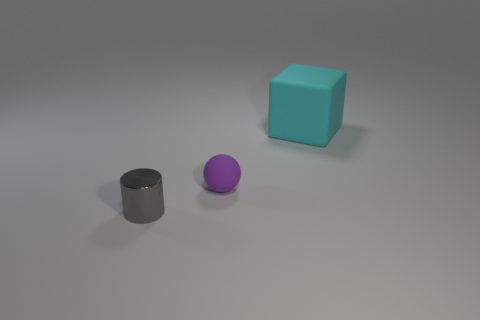Add 3 large cyan blocks. How many objects exist? 6 Subtract all spheres. How many objects are left? 2 Add 1 tiny spheres. How many tiny spheres exist? 2 Subtract 0 brown cylinders. How many objects are left? 3 Subtract all cyan metallic cubes. Subtract all small matte balls. How many objects are left? 2 Add 3 large matte blocks. How many large matte blocks are left? 4 